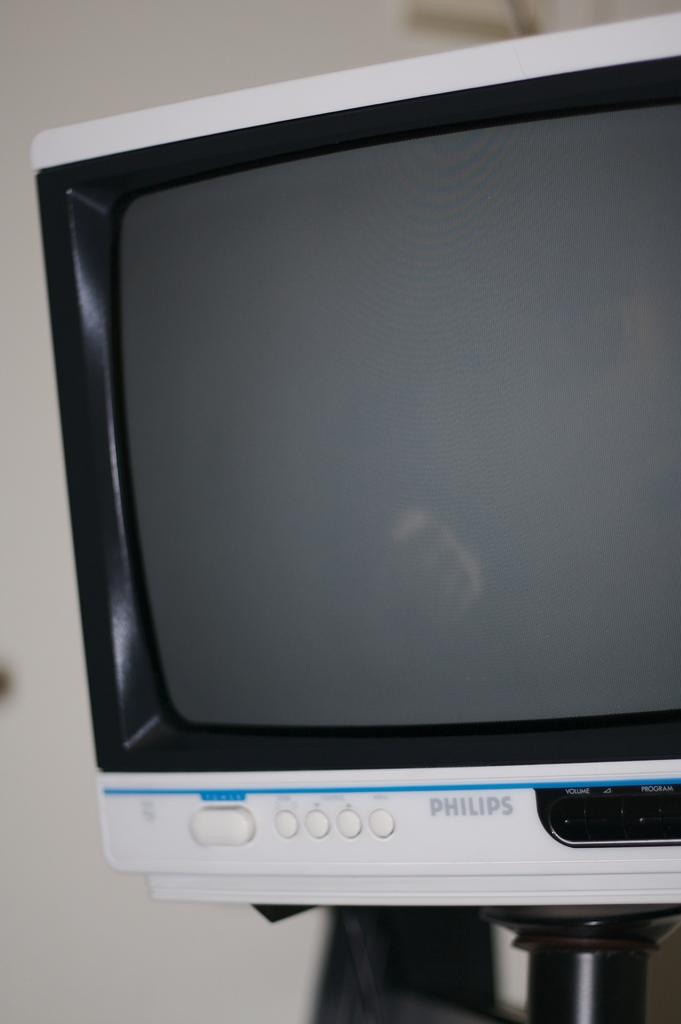<image>
Describe the image concisely. Older version of a Phillips Television displayed on a stand 